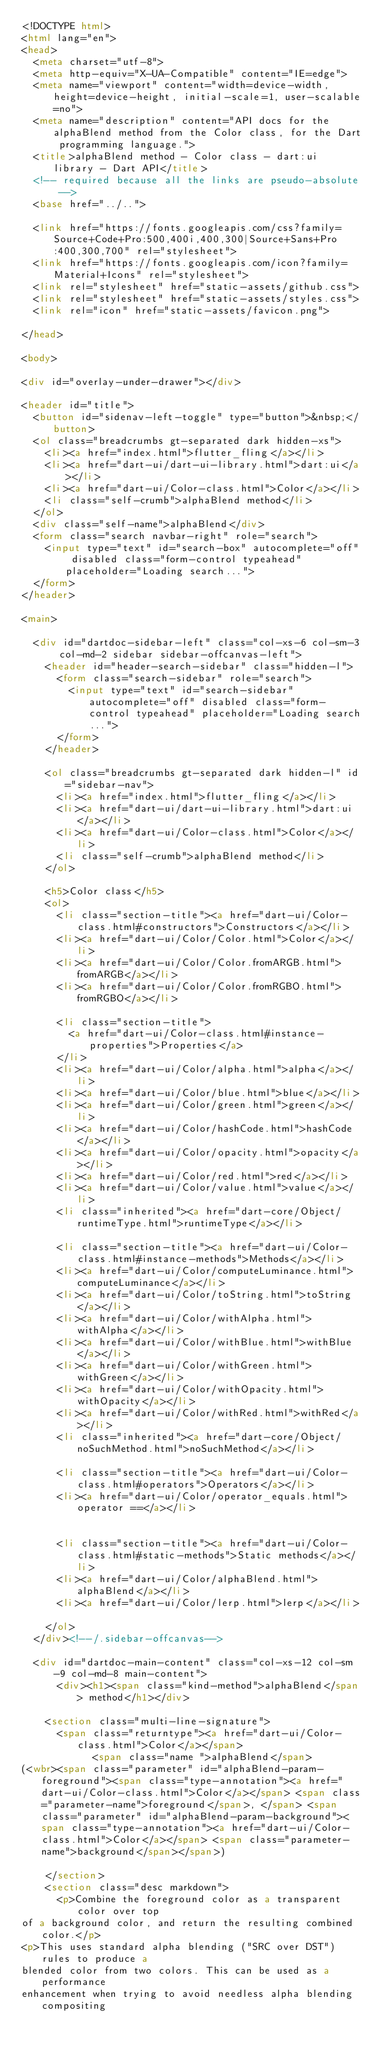<code> <loc_0><loc_0><loc_500><loc_500><_HTML_><!DOCTYPE html>
<html lang="en">
<head>
  <meta charset="utf-8">
  <meta http-equiv="X-UA-Compatible" content="IE=edge">
  <meta name="viewport" content="width=device-width, height=device-height, initial-scale=1, user-scalable=no">
  <meta name="description" content="API docs for the alphaBlend method from the Color class, for the Dart programming language.">
  <title>alphaBlend method - Color class - dart:ui library - Dart API</title>
  <!-- required because all the links are pseudo-absolute -->
  <base href="../..">

  <link href="https://fonts.googleapis.com/css?family=Source+Code+Pro:500,400i,400,300|Source+Sans+Pro:400,300,700" rel="stylesheet">
  <link href="https://fonts.googleapis.com/icon?family=Material+Icons" rel="stylesheet">
  <link rel="stylesheet" href="static-assets/github.css">
  <link rel="stylesheet" href="static-assets/styles.css">
  <link rel="icon" href="static-assets/favicon.png">
  
</head>

<body>

<div id="overlay-under-drawer"></div>

<header id="title">
  <button id="sidenav-left-toggle" type="button">&nbsp;</button>
  <ol class="breadcrumbs gt-separated dark hidden-xs">
    <li><a href="index.html">flutter_fling</a></li>
    <li><a href="dart-ui/dart-ui-library.html">dart:ui</a></li>
    <li><a href="dart-ui/Color-class.html">Color</a></li>
    <li class="self-crumb">alphaBlend method</li>
  </ol>
  <div class="self-name">alphaBlend</div>
  <form class="search navbar-right" role="search">
    <input type="text" id="search-box" autocomplete="off" disabled class="form-control typeahead" placeholder="Loading search...">
  </form>
</header>

<main>

  <div id="dartdoc-sidebar-left" class="col-xs-6 col-sm-3 col-md-2 sidebar sidebar-offcanvas-left">
    <header id="header-search-sidebar" class="hidden-l">
      <form class="search-sidebar" role="search">
        <input type="text" id="search-sidebar" autocomplete="off" disabled class="form-control typeahead" placeholder="Loading search...">
      </form>
    </header>
    
    <ol class="breadcrumbs gt-separated dark hidden-l" id="sidebar-nav">
      <li><a href="index.html">flutter_fling</a></li>
      <li><a href="dart-ui/dart-ui-library.html">dart:ui</a></li>
      <li><a href="dart-ui/Color-class.html">Color</a></li>
      <li class="self-crumb">alphaBlend method</li>
    </ol>
    
    <h5>Color class</h5>
    <ol>
      <li class="section-title"><a href="dart-ui/Color-class.html#constructors">Constructors</a></li>
      <li><a href="dart-ui/Color/Color.html">Color</a></li>
      <li><a href="dart-ui/Color/Color.fromARGB.html">fromARGB</a></li>
      <li><a href="dart-ui/Color/Color.fromRGBO.html">fromRGBO</a></li>
    
      <li class="section-title">
        <a href="dart-ui/Color-class.html#instance-properties">Properties</a>
      </li>
      <li><a href="dart-ui/Color/alpha.html">alpha</a></li>
      <li><a href="dart-ui/Color/blue.html">blue</a></li>
      <li><a href="dart-ui/Color/green.html">green</a></li>
      <li><a href="dart-ui/Color/hashCode.html">hashCode</a></li>
      <li><a href="dart-ui/Color/opacity.html">opacity</a></li>
      <li><a href="dart-ui/Color/red.html">red</a></li>
      <li><a href="dart-ui/Color/value.html">value</a></li>
      <li class="inherited"><a href="dart-core/Object/runtimeType.html">runtimeType</a></li>
    
      <li class="section-title"><a href="dart-ui/Color-class.html#instance-methods">Methods</a></li>
      <li><a href="dart-ui/Color/computeLuminance.html">computeLuminance</a></li>
      <li><a href="dart-ui/Color/toString.html">toString</a></li>
      <li><a href="dart-ui/Color/withAlpha.html">withAlpha</a></li>
      <li><a href="dart-ui/Color/withBlue.html">withBlue</a></li>
      <li><a href="dart-ui/Color/withGreen.html">withGreen</a></li>
      <li><a href="dart-ui/Color/withOpacity.html">withOpacity</a></li>
      <li><a href="dart-ui/Color/withRed.html">withRed</a></li>
      <li class="inherited"><a href="dart-core/Object/noSuchMethod.html">noSuchMethod</a></li>
    
      <li class="section-title"><a href="dart-ui/Color-class.html#operators">Operators</a></li>
      <li><a href="dart-ui/Color/operator_equals.html">operator ==</a></li>
    
    
      <li class="section-title"><a href="dart-ui/Color-class.html#static-methods">Static methods</a></li>
      <li><a href="dart-ui/Color/alphaBlend.html">alphaBlend</a></li>
      <li><a href="dart-ui/Color/lerp.html">lerp</a></li>
    
    </ol>
  </div><!--/.sidebar-offcanvas-->

  <div id="dartdoc-main-content" class="col-xs-12 col-sm-9 col-md-8 main-content">
      <div><h1><span class="kind-method">alphaBlend</span> method</h1></div>

    <section class="multi-line-signature">
      <span class="returntype"><a href="dart-ui/Color-class.html">Color</a></span>
            <span class="name ">alphaBlend</span>
(<wbr><span class="parameter" id="alphaBlend-param-foreground"><span class="type-annotation"><a href="dart-ui/Color-class.html">Color</a></span> <span class="parameter-name">foreground</span>, </span> <span class="parameter" id="alphaBlend-param-background"><span class="type-annotation"><a href="dart-ui/Color-class.html">Color</a></span> <span class="parameter-name">background</span></span>)
      
    </section>
    <section class="desc markdown">
      <p>Combine the foreground color as a transparent color over top
of a background color, and return the resulting combined color.</p>
<p>This uses standard alpha blending ("SRC over DST") rules to produce a
blended color from two colors. This can be used as a performance
enhancement when trying to avoid needless alpha blending compositing</code> 